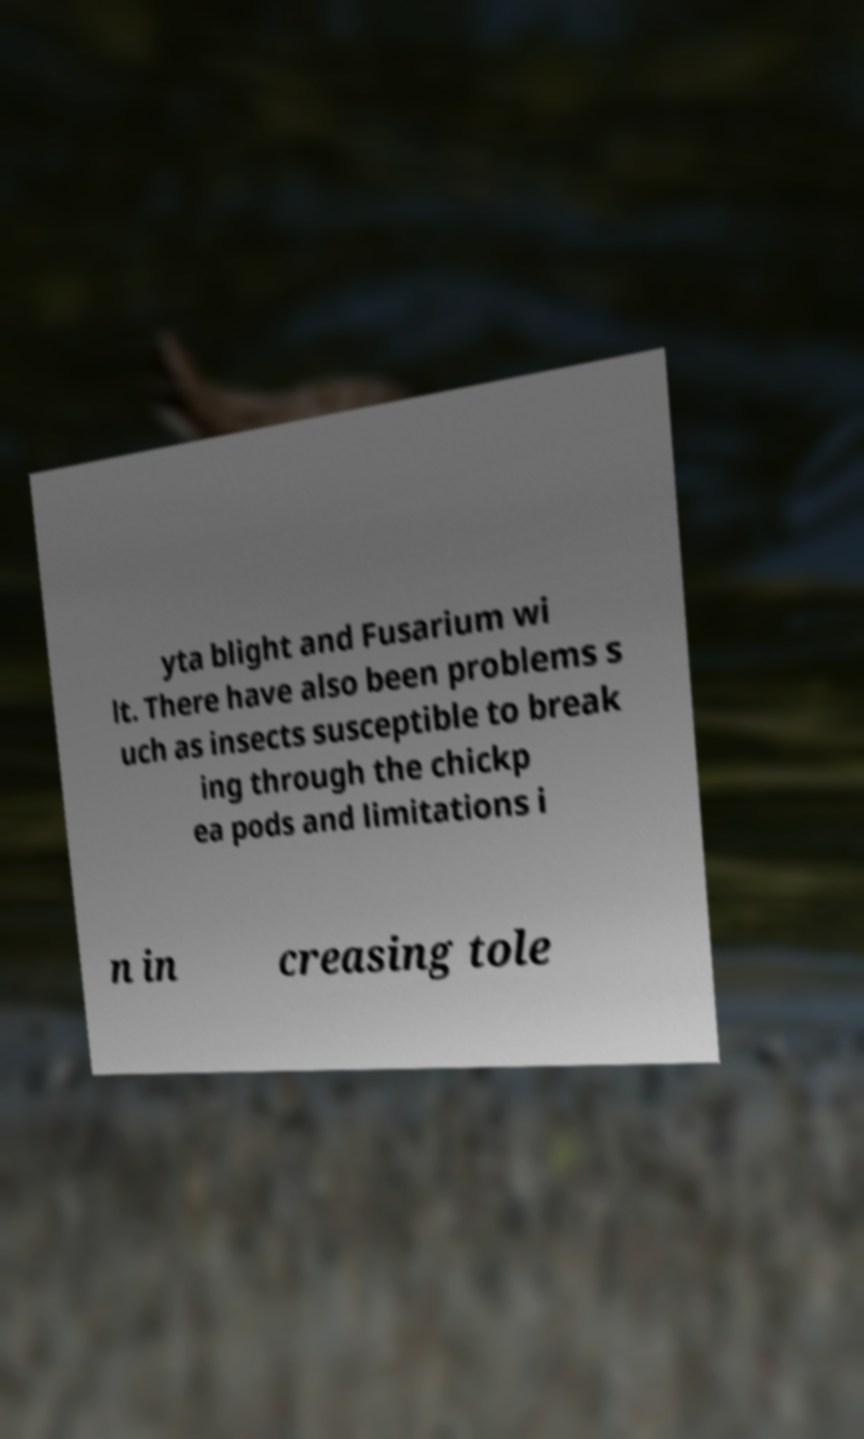For documentation purposes, I need the text within this image transcribed. Could you provide that? yta blight and Fusarium wi lt. There have also been problems s uch as insects susceptible to break ing through the chickp ea pods and limitations i n in creasing tole 